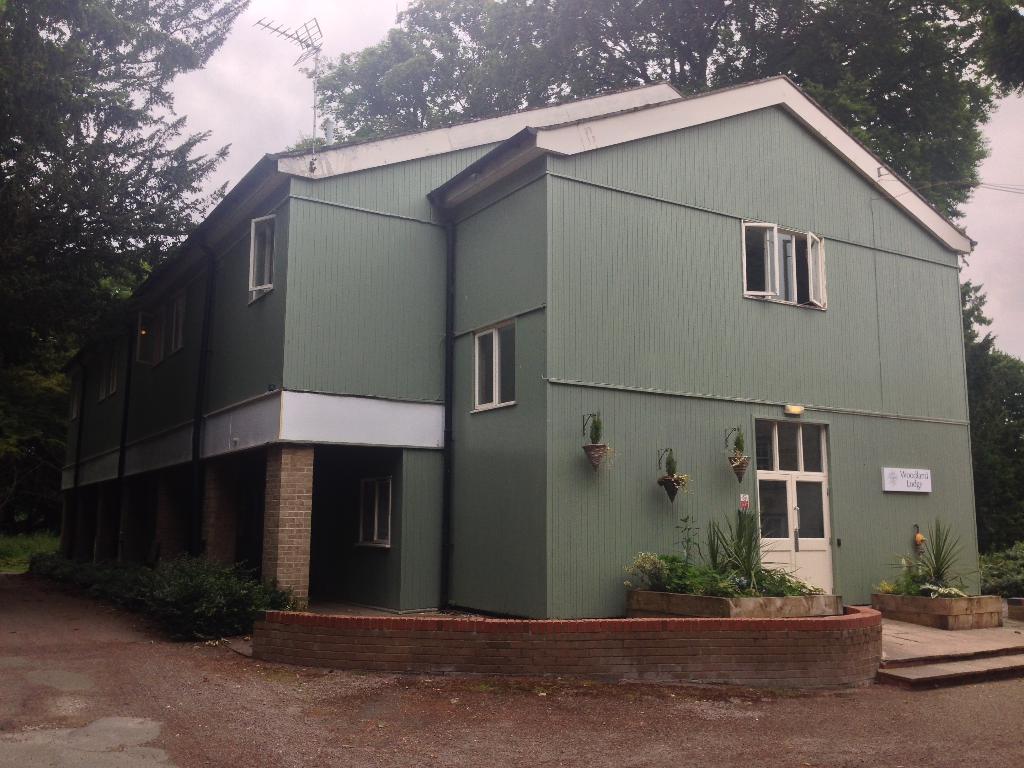Could you give a brief overview of what you see in this image? In this picture I can see the building. On the left I can see planets near to the pillars. In front of the door I can see some plants and grass. In the background I can see many trees. At the top I can see the sky and clouds. At the corner of the building there is a tower. 